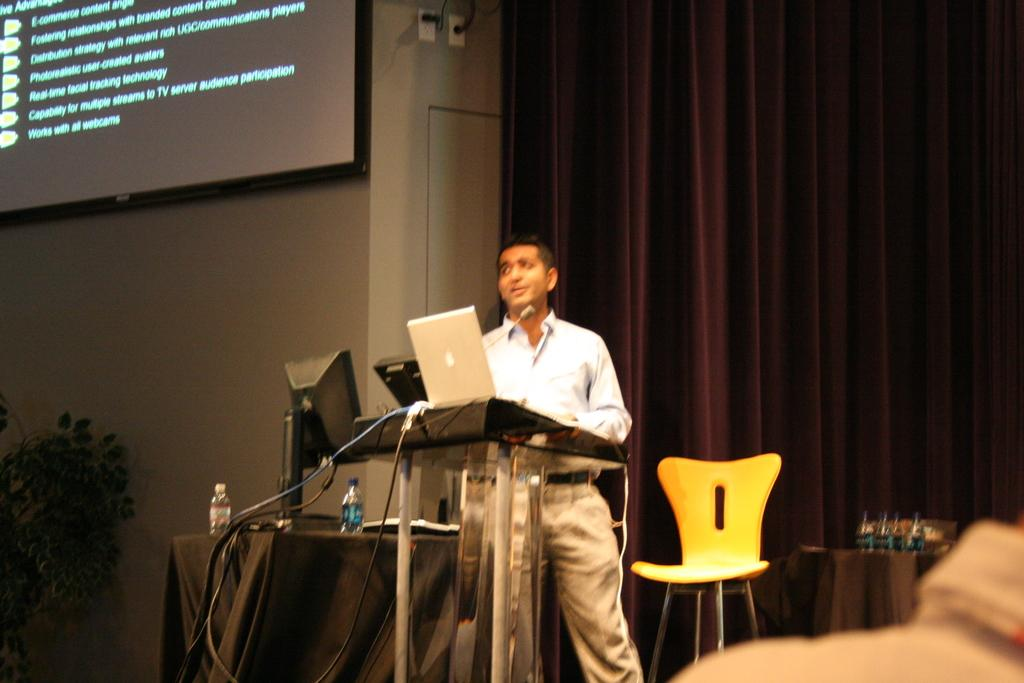What is the main subject of the image? There is a man standing in the center of the image. What is the man standing in front of? The man is in front of a podium. What object does the man have with him? The man has a laptop. What can be seen in the background of the image? There is a chair, a table, and a curtain in the background of the image. What is on the left side of the image? There is a screen and a house plant on the left side of the image. What language are the frogs speaking in the image? There are no frogs present in the image, so it is not possible to determine what language they might be speaking. 